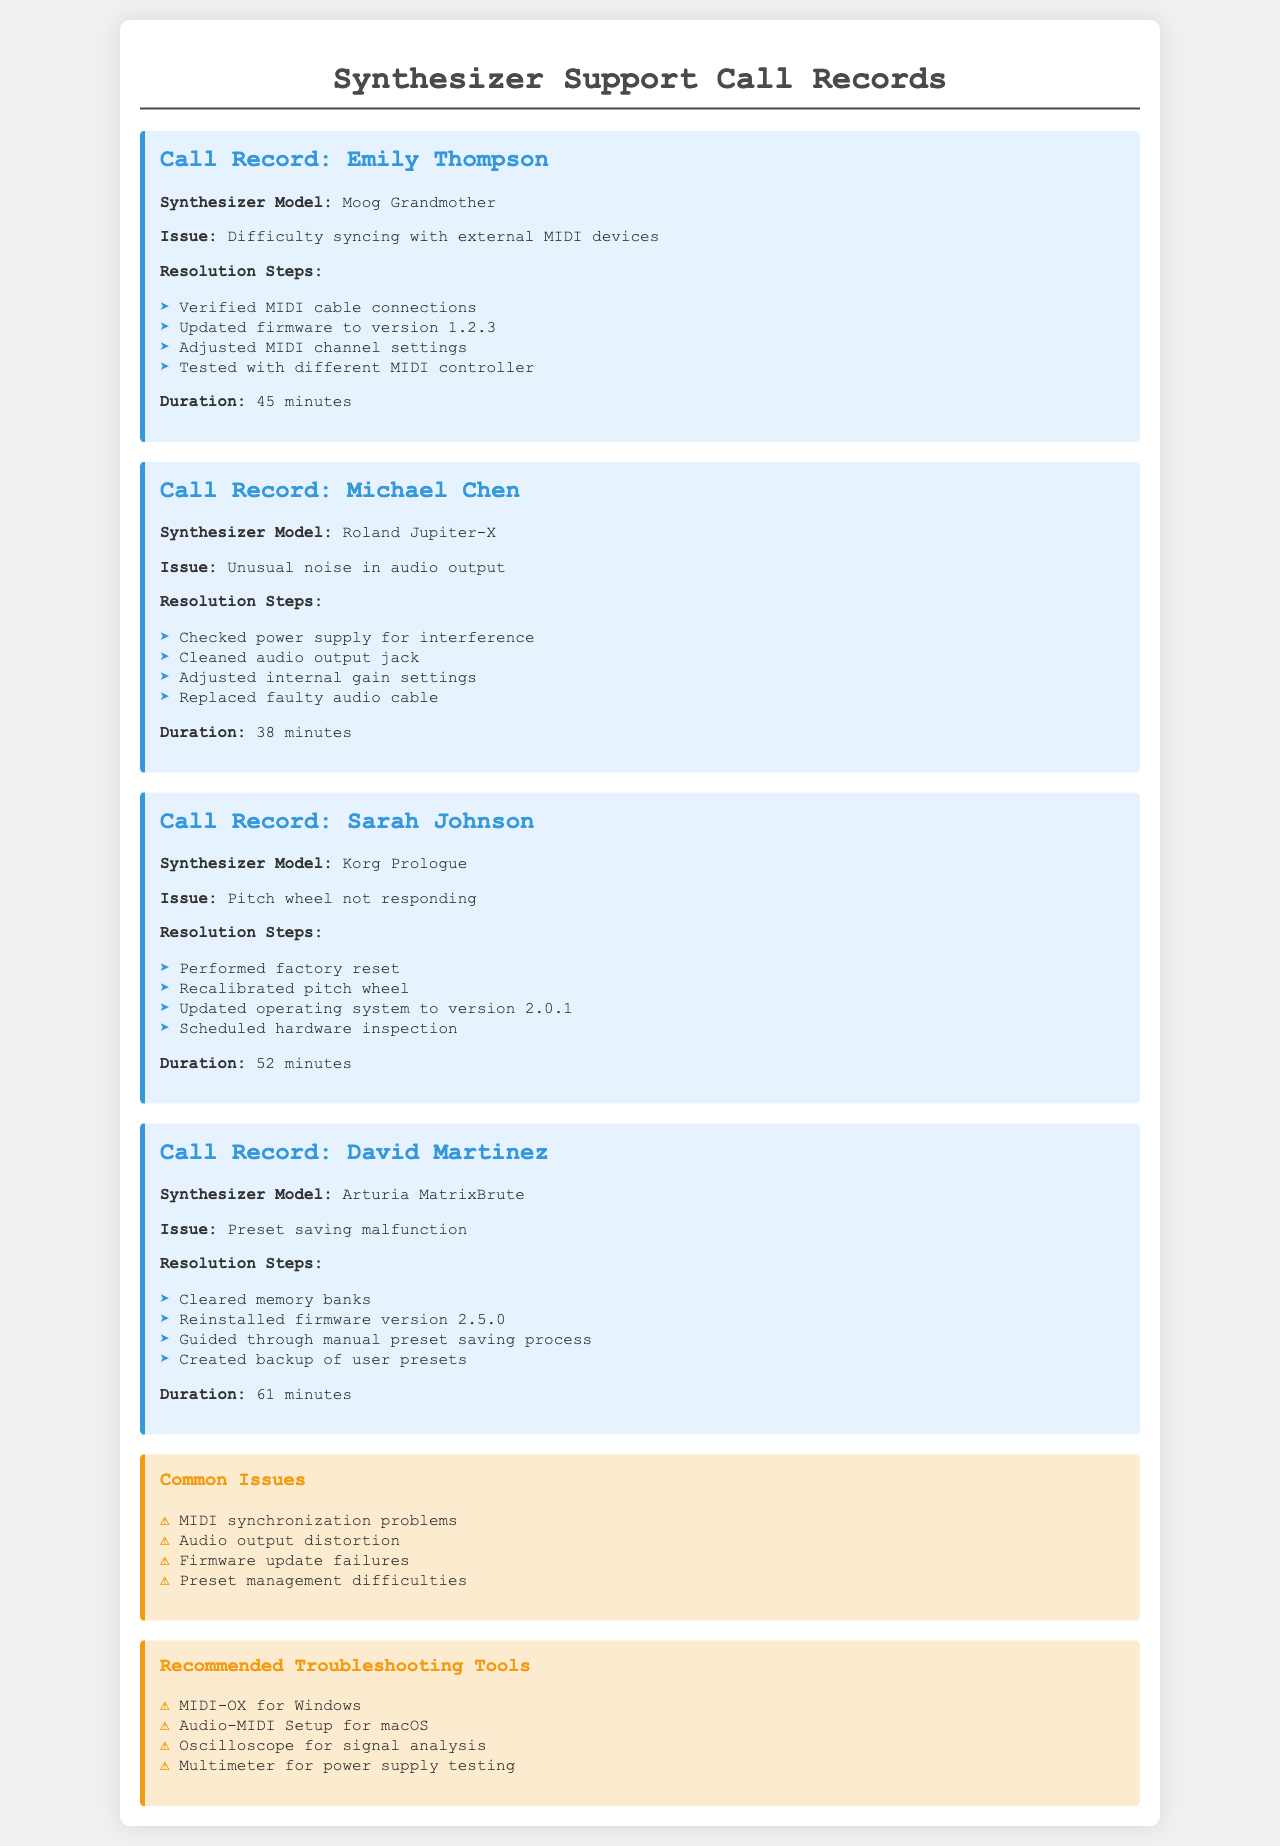what is the duration of Emily Thompson's call? The duration of Emily Thompson's call is explicitly mentioned in the document, which is 45 minutes.
Answer: 45 minutes what issue did Michael Chen report? Michael Chen reported an unusual noise in the audio output, which is stated in his call record.
Answer: Unusual noise in audio output how many minutes did David Martinez's call last? The call duration for David Martinez is listed in the document, which totals to 61 minutes.
Answer: 61 minutes which synthesizer model had a pitch wheel issue? The document specifies that the Korg Prologue had a pitch wheel not responding, as noted in Sarah Johnson's call record.
Answer: Korg Prologue what firmware version was Emily Thompson advised to update to? In Emily Thompson's call record, it mentions updating the firmware to version 1.2.3 as one of the resolution steps.
Answer: 1.2.3 what was a common issue mentioned in the document? The document lists common issues, one of which is MIDI synchronization problems, indicating prevalent concerns among users.
Answer: MIDI synchronization problems how many troubleshooting tools are recommended in the document? The document contains a section on recommended troubleshooting tools, listing a total of four tools.
Answer: Four which synthesizer model had a preset saving malfunction? The Arturia MatrixBrute is indicated as having a preset saving malfunction, as described in David Martinez's call record.
Answer: Arturia MatrixBrute what is one step taken to resolve Sarah Johnson's issue? One of the resolution steps taken for Sarah Johnson's issue was recalibrating the pitch wheel, as detailed in her call record.
Answer: Recalibrated pitch wheel 